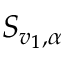<formula> <loc_0><loc_0><loc_500><loc_500>S _ { v _ { 1 } , \alpha }</formula> 